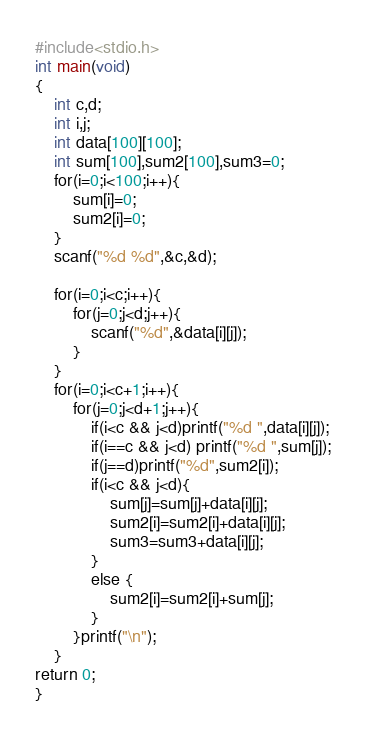Convert code to text. <code><loc_0><loc_0><loc_500><loc_500><_C_>#include<stdio.h>
int main(void)
{
	int c,d;
	int i,j;	
	int data[100][100];
	int sum[100],sum2[100],sum3=0;
	for(i=0;i<100;i++){
		sum[i]=0;
		sum2[i]=0;
	}
	scanf("%d %d",&c,&d);

	for(i=0;i<c;i++){
		for(j=0;j<d;j++){
			scanf("%d",&data[i][j]);
		}
	}
	for(i=0;i<c+1;i++){
		for(j=0;j<d+1;j++){
			if(i<c && j<d)printf("%d ",data[i][j]);
			if(i==c && j<d) printf("%d ",sum[j]);
			if(j==d)printf("%d",sum2[i]);
			if(i<c && j<d){
				sum[j]=sum[j]+data[i][j];
				sum2[i]=sum2[i]+data[i][j];
				sum3=sum3+data[i][j];
			}
			else {
				sum2[i]=sum2[i]+sum[j];
			}
		}printf("\n");
	}
return 0;
}</code> 